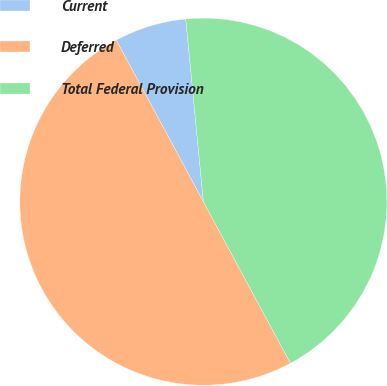<chart> <loc_0><loc_0><loc_500><loc_500><pie_chart><fcel>Current<fcel>Deferred<fcel>Total Federal Provision<nl><fcel>6.34%<fcel>50.0%<fcel>43.66%<nl></chart> 